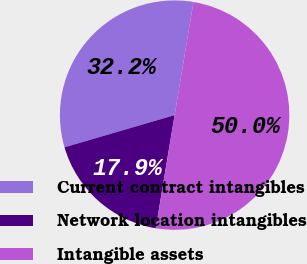Convert chart to OTSL. <chart><loc_0><loc_0><loc_500><loc_500><pie_chart><fcel>Current contract intangibles<fcel>Network location intangibles<fcel>Intangible assets<nl><fcel>32.15%<fcel>17.85%<fcel>50.0%<nl></chart> 